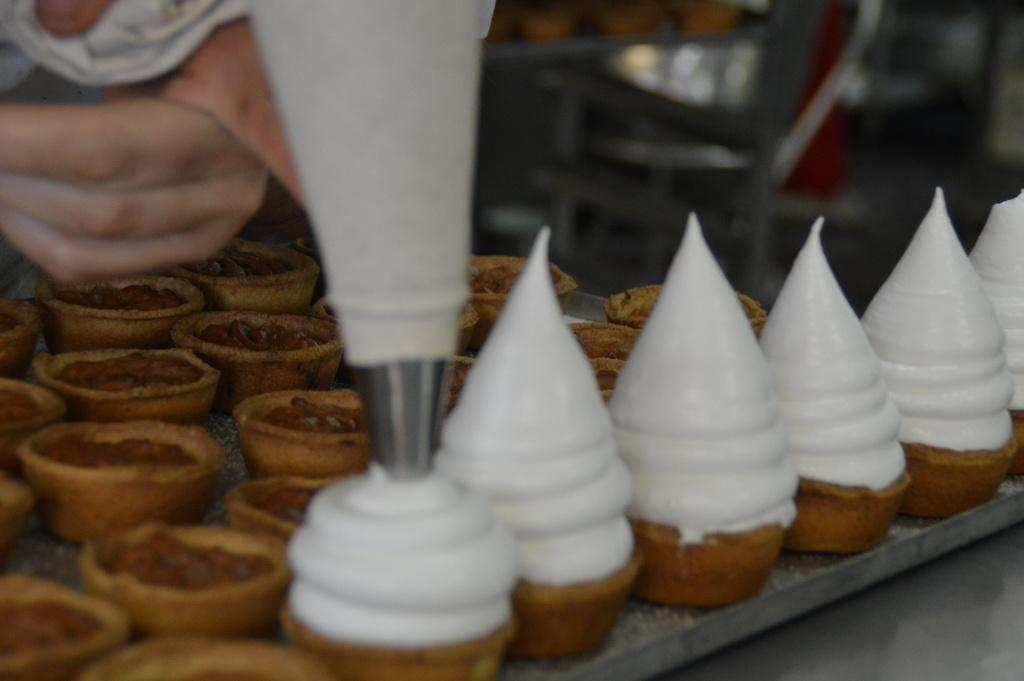What type of dessert is visible in the image? There are ice creams in the image. What type of container is present in the image? There are cups in the image. What type of authority figure can be seen holding a rifle in the image? There is no authority figure or rifle present in the image; it only features ice creams and cups. 